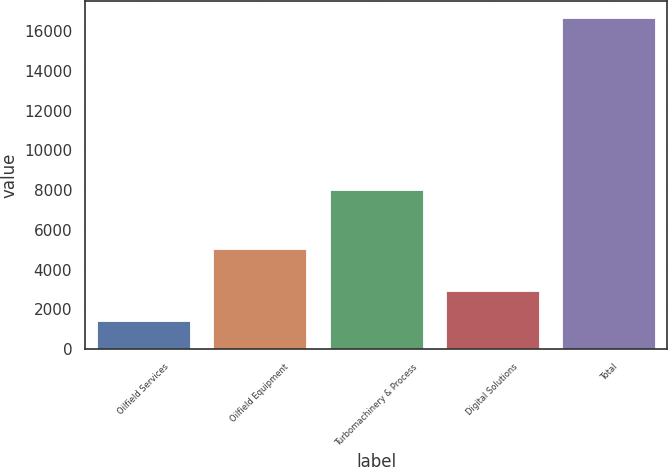Convert chart. <chart><loc_0><loc_0><loc_500><loc_500><bar_chart><fcel>Oilfield Services<fcel>Oilfield Equipment<fcel>Turbomachinery & Process<fcel>Digital Solutions<fcel>Total<nl><fcel>1411<fcel>5060<fcel>7985<fcel>2938.7<fcel>16688<nl></chart> 